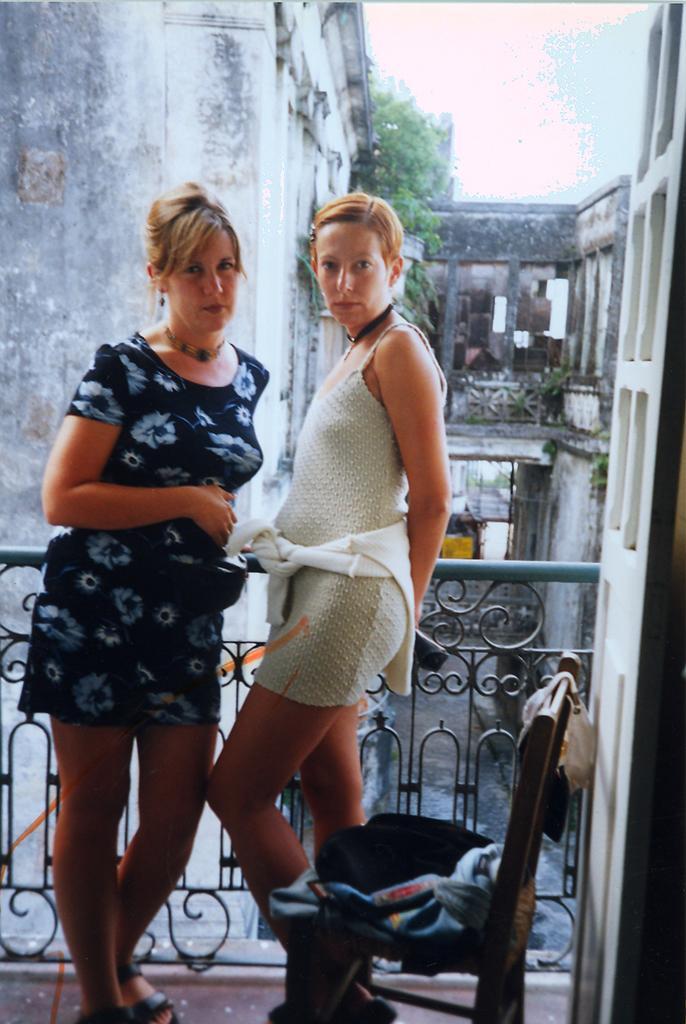Describe this image in one or two sentences. In this picture we can see two women standing, fence, chair with clothes on it, buildings, trees and some objects and in the background we can see the sky. 